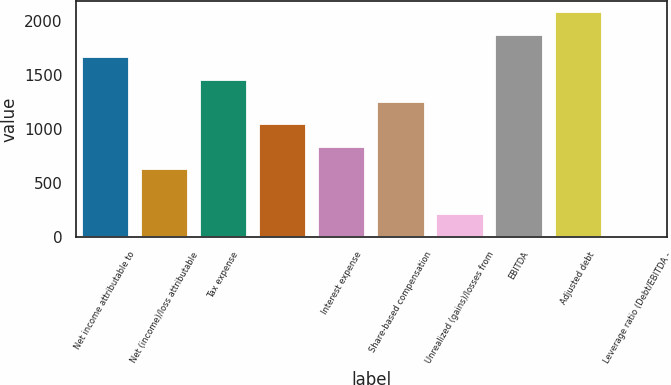Convert chart to OTSL. <chart><loc_0><loc_0><loc_500><loc_500><bar_chart><fcel>Net income attributable to<fcel>Net (income)/loss attributable<fcel>Tax expense<fcel>Unnamed: 3<fcel>Interest expense<fcel>Share-based compensation<fcel>Unrealized (gains)/losses from<fcel>EBITDA<fcel>Adjusted debt<fcel>Leverage ratio (Debt/EBITDA -<nl><fcel>1669.53<fcel>626.83<fcel>1460.99<fcel>1043.91<fcel>835.37<fcel>1252.45<fcel>209.75<fcel>1878.07<fcel>2086.61<fcel>1.21<nl></chart> 